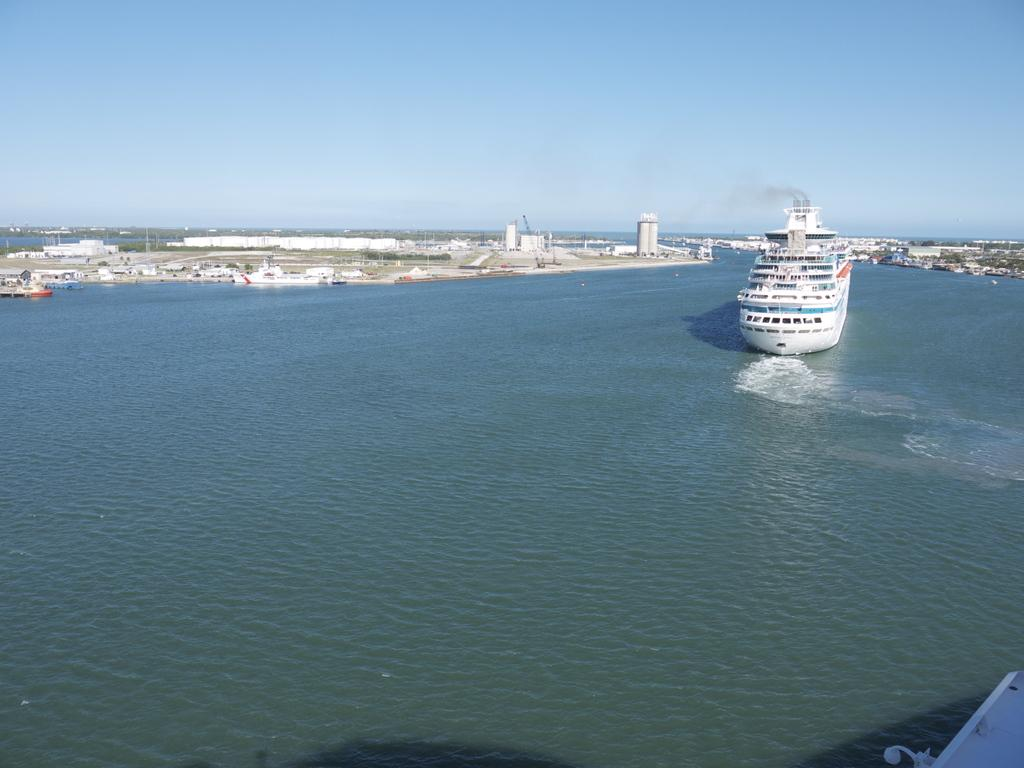What is in the front of the image? There is water in the front of the image. What is happening on the water? There is a ship sailing on the water. What can be seen in the background of the image? There are buildings and boats in the background of the image. Can you see any zephyrs in the image? There are no zephyrs present in the image. Are there any cobwebs visible on the ship in the image? There is no mention of cobwebs in the image, and they would not be visible on a ship sailing on water. 